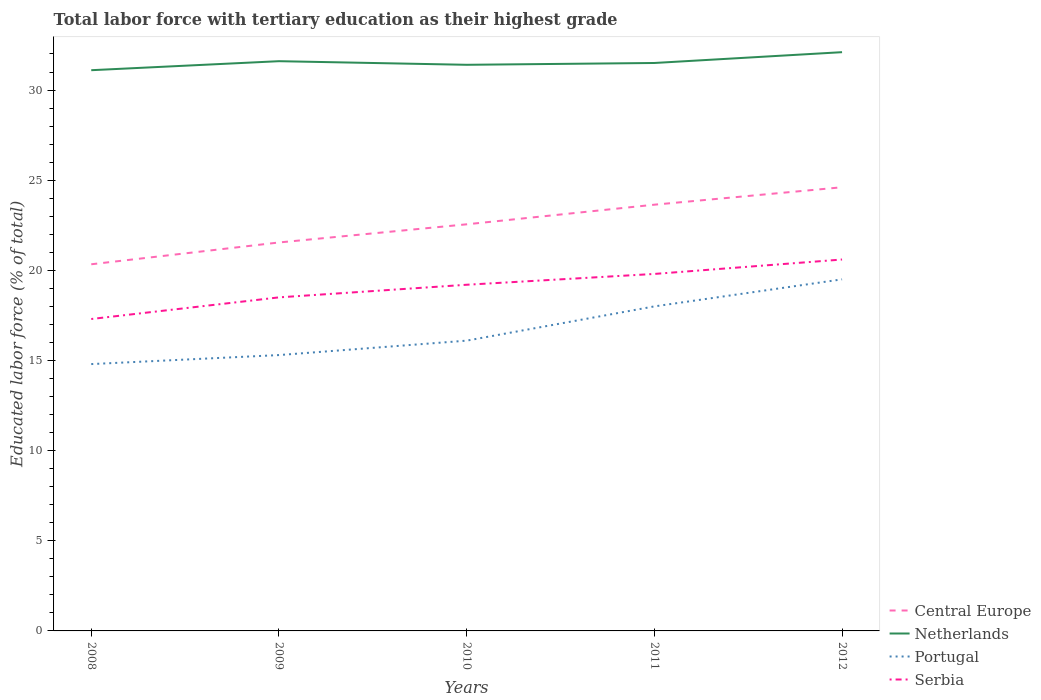How many different coloured lines are there?
Your answer should be compact. 4. Is the number of lines equal to the number of legend labels?
Ensure brevity in your answer.  Yes. Across all years, what is the maximum percentage of male labor force with tertiary education in Serbia?
Your answer should be very brief. 17.3. In which year was the percentage of male labor force with tertiary education in Netherlands maximum?
Make the answer very short. 2008. What is the total percentage of male labor force with tertiary education in Netherlands in the graph?
Ensure brevity in your answer.  0.2. What is the difference between the highest and the second highest percentage of male labor force with tertiary education in Central Europe?
Offer a terse response. 4.27. Is the percentage of male labor force with tertiary education in Central Europe strictly greater than the percentage of male labor force with tertiary education in Serbia over the years?
Your answer should be very brief. No. What is the difference between two consecutive major ticks on the Y-axis?
Make the answer very short. 5. Does the graph contain grids?
Offer a terse response. No. Where does the legend appear in the graph?
Provide a succinct answer. Bottom right. How many legend labels are there?
Provide a succinct answer. 4. What is the title of the graph?
Your answer should be very brief. Total labor force with tertiary education as their highest grade. What is the label or title of the Y-axis?
Ensure brevity in your answer.  Educated labor force (% of total). What is the Educated labor force (% of total) of Central Europe in 2008?
Ensure brevity in your answer.  20.34. What is the Educated labor force (% of total) of Netherlands in 2008?
Provide a short and direct response. 31.1. What is the Educated labor force (% of total) of Portugal in 2008?
Offer a very short reply. 14.8. What is the Educated labor force (% of total) of Serbia in 2008?
Your response must be concise. 17.3. What is the Educated labor force (% of total) of Central Europe in 2009?
Ensure brevity in your answer.  21.55. What is the Educated labor force (% of total) of Netherlands in 2009?
Make the answer very short. 31.6. What is the Educated labor force (% of total) in Portugal in 2009?
Give a very brief answer. 15.3. What is the Educated labor force (% of total) of Central Europe in 2010?
Your answer should be compact. 22.55. What is the Educated labor force (% of total) of Netherlands in 2010?
Your response must be concise. 31.4. What is the Educated labor force (% of total) in Portugal in 2010?
Offer a terse response. 16.1. What is the Educated labor force (% of total) in Serbia in 2010?
Your answer should be very brief. 19.2. What is the Educated labor force (% of total) in Central Europe in 2011?
Provide a short and direct response. 23.64. What is the Educated labor force (% of total) of Netherlands in 2011?
Your answer should be very brief. 31.5. What is the Educated labor force (% of total) of Portugal in 2011?
Make the answer very short. 18. What is the Educated labor force (% of total) in Serbia in 2011?
Ensure brevity in your answer.  19.8. What is the Educated labor force (% of total) in Central Europe in 2012?
Provide a short and direct response. 24.61. What is the Educated labor force (% of total) in Netherlands in 2012?
Provide a short and direct response. 32.1. What is the Educated labor force (% of total) of Serbia in 2012?
Offer a very short reply. 20.6. Across all years, what is the maximum Educated labor force (% of total) in Central Europe?
Ensure brevity in your answer.  24.61. Across all years, what is the maximum Educated labor force (% of total) in Netherlands?
Your response must be concise. 32.1. Across all years, what is the maximum Educated labor force (% of total) in Portugal?
Keep it short and to the point. 19.5. Across all years, what is the maximum Educated labor force (% of total) in Serbia?
Keep it short and to the point. 20.6. Across all years, what is the minimum Educated labor force (% of total) in Central Europe?
Provide a succinct answer. 20.34. Across all years, what is the minimum Educated labor force (% of total) of Netherlands?
Make the answer very short. 31.1. Across all years, what is the minimum Educated labor force (% of total) of Portugal?
Make the answer very short. 14.8. Across all years, what is the minimum Educated labor force (% of total) of Serbia?
Give a very brief answer. 17.3. What is the total Educated labor force (% of total) of Central Europe in the graph?
Your answer should be compact. 112.68. What is the total Educated labor force (% of total) of Netherlands in the graph?
Give a very brief answer. 157.7. What is the total Educated labor force (% of total) of Portugal in the graph?
Your response must be concise. 83.7. What is the total Educated labor force (% of total) of Serbia in the graph?
Provide a short and direct response. 95.4. What is the difference between the Educated labor force (% of total) in Central Europe in 2008 and that in 2009?
Your answer should be compact. -1.21. What is the difference between the Educated labor force (% of total) of Netherlands in 2008 and that in 2009?
Make the answer very short. -0.5. What is the difference between the Educated labor force (% of total) in Central Europe in 2008 and that in 2010?
Make the answer very short. -2.22. What is the difference between the Educated labor force (% of total) of Netherlands in 2008 and that in 2010?
Give a very brief answer. -0.3. What is the difference between the Educated labor force (% of total) in Portugal in 2008 and that in 2010?
Give a very brief answer. -1.3. What is the difference between the Educated labor force (% of total) of Central Europe in 2008 and that in 2011?
Provide a short and direct response. -3.3. What is the difference between the Educated labor force (% of total) in Portugal in 2008 and that in 2011?
Your response must be concise. -3.2. What is the difference between the Educated labor force (% of total) of Central Europe in 2008 and that in 2012?
Provide a short and direct response. -4.27. What is the difference between the Educated labor force (% of total) in Serbia in 2008 and that in 2012?
Your answer should be compact. -3.3. What is the difference between the Educated labor force (% of total) in Central Europe in 2009 and that in 2010?
Give a very brief answer. -1.01. What is the difference between the Educated labor force (% of total) of Netherlands in 2009 and that in 2010?
Give a very brief answer. 0.2. What is the difference between the Educated labor force (% of total) in Serbia in 2009 and that in 2010?
Provide a short and direct response. -0.7. What is the difference between the Educated labor force (% of total) of Central Europe in 2009 and that in 2011?
Your answer should be compact. -2.1. What is the difference between the Educated labor force (% of total) in Netherlands in 2009 and that in 2011?
Provide a succinct answer. 0.1. What is the difference between the Educated labor force (% of total) of Portugal in 2009 and that in 2011?
Give a very brief answer. -2.7. What is the difference between the Educated labor force (% of total) of Serbia in 2009 and that in 2011?
Provide a short and direct response. -1.3. What is the difference between the Educated labor force (% of total) in Central Europe in 2009 and that in 2012?
Give a very brief answer. -3.06. What is the difference between the Educated labor force (% of total) of Portugal in 2009 and that in 2012?
Your answer should be very brief. -4.2. What is the difference between the Educated labor force (% of total) in Central Europe in 2010 and that in 2011?
Provide a succinct answer. -1.09. What is the difference between the Educated labor force (% of total) in Netherlands in 2010 and that in 2011?
Ensure brevity in your answer.  -0.1. What is the difference between the Educated labor force (% of total) of Portugal in 2010 and that in 2011?
Give a very brief answer. -1.9. What is the difference between the Educated labor force (% of total) in Central Europe in 2010 and that in 2012?
Offer a terse response. -2.06. What is the difference between the Educated labor force (% of total) of Netherlands in 2010 and that in 2012?
Your answer should be compact. -0.7. What is the difference between the Educated labor force (% of total) in Portugal in 2010 and that in 2012?
Offer a terse response. -3.4. What is the difference between the Educated labor force (% of total) in Central Europe in 2011 and that in 2012?
Make the answer very short. -0.97. What is the difference between the Educated labor force (% of total) of Central Europe in 2008 and the Educated labor force (% of total) of Netherlands in 2009?
Provide a short and direct response. -11.26. What is the difference between the Educated labor force (% of total) in Central Europe in 2008 and the Educated labor force (% of total) in Portugal in 2009?
Give a very brief answer. 5.04. What is the difference between the Educated labor force (% of total) in Central Europe in 2008 and the Educated labor force (% of total) in Serbia in 2009?
Keep it short and to the point. 1.84. What is the difference between the Educated labor force (% of total) of Central Europe in 2008 and the Educated labor force (% of total) of Netherlands in 2010?
Ensure brevity in your answer.  -11.06. What is the difference between the Educated labor force (% of total) in Central Europe in 2008 and the Educated labor force (% of total) in Portugal in 2010?
Provide a succinct answer. 4.24. What is the difference between the Educated labor force (% of total) in Central Europe in 2008 and the Educated labor force (% of total) in Serbia in 2010?
Your answer should be compact. 1.14. What is the difference between the Educated labor force (% of total) in Netherlands in 2008 and the Educated labor force (% of total) in Portugal in 2010?
Keep it short and to the point. 15. What is the difference between the Educated labor force (% of total) of Netherlands in 2008 and the Educated labor force (% of total) of Serbia in 2010?
Offer a very short reply. 11.9. What is the difference between the Educated labor force (% of total) of Central Europe in 2008 and the Educated labor force (% of total) of Netherlands in 2011?
Make the answer very short. -11.16. What is the difference between the Educated labor force (% of total) of Central Europe in 2008 and the Educated labor force (% of total) of Portugal in 2011?
Provide a short and direct response. 2.34. What is the difference between the Educated labor force (% of total) in Central Europe in 2008 and the Educated labor force (% of total) in Serbia in 2011?
Offer a very short reply. 0.54. What is the difference between the Educated labor force (% of total) in Netherlands in 2008 and the Educated labor force (% of total) in Portugal in 2011?
Your answer should be very brief. 13.1. What is the difference between the Educated labor force (% of total) in Portugal in 2008 and the Educated labor force (% of total) in Serbia in 2011?
Your answer should be very brief. -5. What is the difference between the Educated labor force (% of total) of Central Europe in 2008 and the Educated labor force (% of total) of Netherlands in 2012?
Your response must be concise. -11.76. What is the difference between the Educated labor force (% of total) in Central Europe in 2008 and the Educated labor force (% of total) in Portugal in 2012?
Give a very brief answer. 0.84. What is the difference between the Educated labor force (% of total) in Central Europe in 2008 and the Educated labor force (% of total) in Serbia in 2012?
Give a very brief answer. -0.26. What is the difference between the Educated labor force (% of total) of Netherlands in 2008 and the Educated labor force (% of total) of Serbia in 2012?
Provide a succinct answer. 10.5. What is the difference between the Educated labor force (% of total) of Portugal in 2008 and the Educated labor force (% of total) of Serbia in 2012?
Your answer should be very brief. -5.8. What is the difference between the Educated labor force (% of total) of Central Europe in 2009 and the Educated labor force (% of total) of Netherlands in 2010?
Make the answer very short. -9.85. What is the difference between the Educated labor force (% of total) in Central Europe in 2009 and the Educated labor force (% of total) in Portugal in 2010?
Your response must be concise. 5.45. What is the difference between the Educated labor force (% of total) of Central Europe in 2009 and the Educated labor force (% of total) of Serbia in 2010?
Your response must be concise. 2.35. What is the difference between the Educated labor force (% of total) of Portugal in 2009 and the Educated labor force (% of total) of Serbia in 2010?
Your answer should be very brief. -3.9. What is the difference between the Educated labor force (% of total) of Central Europe in 2009 and the Educated labor force (% of total) of Netherlands in 2011?
Your response must be concise. -9.95. What is the difference between the Educated labor force (% of total) in Central Europe in 2009 and the Educated labor force (% of total) in Portugal in 2011?
Your answer should be compact. 3.55. What is the difference between the Educated labor force (% of total) in Central Europe in 2009 and the Educated labor force (% of total) in Serbia in 2011?
Offer a very short reply. 1.75. What is the difference between the Educated labor force (% of total) of Central Europe in 2009 and the Educated labor force (% of total) of Netherlands in 2012?
Keep it short and to the point. -10.55. What is the difference between the Educated labor force (% of total) in Central Europe in 2009 and the Educated labor force (% of total) in Portugal in 2012?
Ensure brevity in your answer.  2.05. What is the difference between the Educated labor force (% of total) of Central Europe in 2009 and the Educated labor force (% of total) of Serbia in 2012?
Provide a succinct answer. 0.95. What is the difference between the Educated labor force (% of total) in Netherlands in 2009 and the Educated labor force (% of total) in Portugal in 2012?
Offer a very short reply. 12.1. What is the difference between the Educated labor force (% of total) in Portugal in 2009 and the Educated labor force (% of total) in Serbia in 2012?
Make the answer very short. -5.3. What is the difference between the Educated labor force (% of total) of Central Europe in 2010 and the Educated labor force (% of total) of Netherlands in 2011?
Offer a very short reply. -8.95. What is the difference between the Educated labor force (% of total) of Central Europe in 2010 and the Educated labor force (% of total) of Portugal in 2011?
Offer a terse response. 4.55. What is the difference between the Educated labor force (% of total) in Central Europe in 2010 and the Educated labor force (% of total) in Serbia in 2011?
Make the answer very short. 2.75. What is the difference between the Educated labor force (% of total) of Netherlands in 2010 and the Educated labor force (% of total) of Portugal in 2011?
Your answer should be very brief. 13.4. What is the difference between the Educated labor force (% of total) of Netherlands in 2010 and the Educated labor force (% of total) of Serbia in 2011?
Offer a terse response. 11.6. What is the difference between the Educated labor force (% of total) in Portugal in 2010 and the Educated labor force (% of total) in Serbia in 2011?
Provide a short and direct response. -3.7. What is the difference between the Educated labor force (% of total) in Central Europe in 2010 and the Educated labor force (% of total) in Netherlands in 2012?
Your answer should be very brief. -9.55. What is the difference between the Educated labor force (% of total) in Central Europe in 2010 and the Educated labor force (% of total) in Portugal in 2012?
Keep it short and to the point. 3.05. What is the difference between the Educated labor force (% of total) of Central Europe in 2010 and the Educated labor force (% of total) of Serbia in 2012?
Provide a short and direct response. 1.95. What is the difference between the Educated labor force (% of total) of Netherlands in 2010 and the Educated labor force (% of total) of Serbia in 2012?
Your answer should be compact. 10.8. What is the difference between the Educated labor force (% of total) of Portugal in 2010 and the Educated labor force (% of total) of Serbia in 2012?
Your answer should be very brief. -4.5. What is the difference between the Educated labor force (% of total) of Central Europe in 2011 and the Educated labor force (% of total) of Netherlands in 2012?
Give a very brief answer. -8.46. What is the difference between the Educated labor force (% of total) in Central Europe in 2011 and the Educated labor force (% of total) in Portugal in 2012?
Make the answer very short. 4.14. What is the difference between the Educated labor force (% of total) in Central Europe in 2011 and the Educated labor force (% of total) in Serbia in 2012?
Offer a very short reply. 3.04. What is the difference between the Educated labor force (% of total) in Netherlands in 2011 and the Educated labor force (% of total) in Portugal in 2012?
Keep it short and to the point. 12. What is the difference between the Educated labor force (% of total) in Netherlands in 2011 and the Educated labor force (% of total) in Serbia in 2012?
Ensure brevity in your answer.  10.9. What is the difference between the Educated labor force (% of total) in Portugal in 2011 and the Educated labor force (% of total) in Serbia in 2012?
Your answer should be compact. -2.6. What is the average Educated labor force (% of total) of Central Europe per year?
Offer a terse response. 22.54. What is the average Educated labor force (% of total) of Netherlands per year?
Give a very brief answer. 31.54. What is the average Educated labor force (% of total) of Portugal per year?
Give a very brief answer. 16.74. What is the average Educated labor force (% of total) in Serbia per year?
Keep it short and to the point. 19.08. In the year 2008, what is the difference between the Educated labor force (% of total) in Central Europe and Educated labor force (% of total) in Netherlands?
Keep it short and to the point. -10.76. In the year 2008, what is the difference between the Educated labor force (% of total) of Central Europe and Educated labor force (% of total) of Portugal?
Your response must be concise. 5.54. In the year 2008, what is the difference between the Educated labor force (% of total) in Central Europe and Educated labor force (% of total) in Serbia?
Offer a very short reply. 3.04. In the year 2008, what is the difference between the Educated labor force (% of total) of Netherlands and Educated labor force (% of total) of Portugal?
Offer a very short reply. 16.3. In the year 2008, what is the difference between the Educated labor force (% of total) of Portugal and Educated labor force (% of total) of Serbia?
Provide a succinct answer. -2.5. In the year 2009, what is the difference between the Educated labor force (% of total) of Central Europe and Educated labor force (% of total) of Netherlands?
Make the answer very short. -10.05. In the year 2009, what is the difference between the Educated labor force (% of total) of Central Europe and Educated labor force (% of total) of Portugal?
Provide a short and direct response. 6.25. In the year 2009, what is the difference between the Educated labor force (% of total) of Central Europe and Educated labor force (% of total) of Serbia?
Offer a very short reply. 3.05. In the year 2009, what is the difference between the Educated labor force (% of total) of Netherlands and Educated labor force (% of total) of Portugal?
Your answer should be very brief. 16.3. In the year 2010, what is the difference between the Educated labor force (% of total) of Central Europe and Educated labor force (% of total) of Netherlands?
Make the answer very short. -8.85. In the year 2010, what is the difference between the Educated labor force (% of total) of Central Europe and Educated labor force (% of total) of Portugal?
Provide a short and direct response. 6.45. In the year 2010, what is the difference between the Educated labor force (% of total) in Central Europe and Educated labor force (% of total) in Serbia?
Your response must be concise. 3.35. In the year 2010, what is the difference between the Educated labor force (% of total) of Portugal and Educated labor force (% of total) of Serbia?
Provide a short and direct response. -3.1. In the year 2011, what is the difference between the Educated labor force (% of total) in Central Europe and Educated labor force (% of total) in Netherlands?
Your answer should be compact. -7.86. In the year 2011, what is the difference between the Educated labor force (% of total) in Central Europe and Educated labor force (% of total) in Portugal?
Your answer should be compact. 5.64. In the year 2011, what is the difference between the Educated labor force (% of total) of Central Europe and Educated labor force (% of total) of Serbia?
Ensure brevity in your answer.  3.84. In the year 2011, what is the difference between the Educated labor force (% of total) of Netherlands and Educated labor force (% of total) of Serbia?
Provide a succinct answer. 11.7. In the year 2011, what is the difference between the Educated labor force (% of total) of Portugal and Educated labor force (% of total) of Serbia?
Make the answer very short. -1.8. In the year 2012, what is the difference between the Educated labor force (% of total) of Central Europe and Educated labor force (% of total) of Netherlands?
Give a very brief answer. -7.49. In the year 2012, what is the difference between the Educated labor force (% of total) of Central Europe and Educated labor force (% of total) of Portugal?
Your response must be concise. 5.11. In the year 2012, what is the difference between the Educated labor force (% of total) in Central Europe and Educated labor force (% of total) in Serbia?
Provide a short and direct response. 4.01. What is the ratio of the Educated labor force (% of total) of Central Europe in 2008 to that in 2009?
Your response must be concise. 0.94. What is the ratio of the Educated labor force (% of total) of Netherlands in 2008 to that in 2009?
Your answer should be very brief. 0.98. What is the ratio of the Educated labor force (% of total) in Portugal in 2008 to that in 2009?
Provide a succinct answer. 0.97. What is the ratio of the Educated labor force (% of total) in Serbia in 2008 to that in 2009?
Offer a very short reply. 0.94. What is the ratio of the Educated labor force (% of total) of Central Europe in 2008 to that in 2010?
Your answer should be compact. 0.9. What is the ratio of the Educated labor force (% of total) of Portugal in 2008 to that in 2010?
Your answer should be compact. 0.92. What is the ratio of the Educated labor force (% of total) in Serbia in 2008 to that in 2010?
Offer a terse response. 0.9. What is the ratio of the Educated labor force (% of total) in Central Europe in 2008 to that in 2011?
Keep it short and to the point. 0.86. What is the ratio of the Educated labor force (% of total) in Netherlands in 2008 to that in 2011?
Provide a short and direct response. 0.99. What is the ratio of the Educated labor force (% of total) of Portugal in 2008 to that in 2011?
Offer a terse response. 0.82. What is the ratio of the Educated labor force (% of total) in Serbia in 2008 to that in 2011?
Your answer should be compact. 0.87. What is the ratio of the Educated labor force (% of total) of Central Europe in 2008 to that in 2012?
Provide a short and direct response. 0.83. What is the ratio of the Educated labor force (% of total) of Netherlands in 2008 to that in 2012?
Provide a short and direct response. 0.97. What is the ratio of the Educated labor force (% of total) of Portugal in 2008 to that in 2012?
Offer a terse response. 0.76. What is the ratio of the Educated labor force (% of total) in Serbia in 2008 to that in 2012?
Provide a short and direct response. 0.84. What is the ratio of the Educated labor force (% of total) of Central Europe in 2009 to that in 2010?
Offer a very short reply. 0.96. What is the ratio of the Educated labor force (% of total) of Netherlands in 2009 to that in 2010?
Offer a terse response. 1.01. What is the ratio of the Educated labor force (% of total) of Portugal in 2009 to that in 2010?
Provide a succinct answer. 0.95. What is the ratio of the Educated labor force (% of total) in Serbia in 2009 to that in 2010?
Provide a succinct answer. 0.96. What is the ratio of the Educated labor force (% of total) in Central Europe in 2009 to that in 2011?
Your answer should be compact. 0.91. What is the ratio of the Educated labor force (% of total) in Portugal in 2009 to that in 2011?
Your response must be concise. 0.85. What is the ratio of the Educated labor force (% of total) in Serbia in 2009 to that in 2011?
Provide a short and direct response. 0.93. What is the ratio of the Educated labor force (% of total) of Central Europe in 2009 to that in 2012?
Give a very brief answer. 0.88. What is the ratio of the Educated labor force (% of total) of Netherlands in 2009 to that in 2012?
Ensure brevity in your answer.  0.98. What is the ratio of the Educated labor force (% of total) of Portugal in 2009 to that in 2012?
Make the answer very short. 0.78. What is the ratio of the Educated labor force (% of total) of Serbia in 2009 to that in 2012?
Make the answer very short. 0.9. What is the ratio of the Educated labor force (% of total) in Central Europe in 2010 to that in 2011?
Provide a succinct answer. 0.95. What is the ratio of the Educated labor force (% of total) of Netherlands in 2010 to that in 2011?
Offer a terse response. 1. What is the ratio of the Educated labor force (% of total) in Portugal in 2010 to that in 2011?
Give a very brief answer. 0.89. What is the ratio of the Educated labor force (% of total) in Serbia in 2010 to that in 2011?
Provide a short and direct response. 0.97. What is the ratio of the Educated labor force (% of total) in Central Europe in 2010 to that in 2012?
Ensure brevity in your answer.  0.92. What is the ratio of the Educated labor force (% of total) in Netherlands in 2010 to that in 2012?
Give a very brief answer. 0.98. What is the ratio of the Educated labor force (% of total) of Portugal in 2010 to that in 2012?
Your answer should be very brief. 0.83. What is the ratio of the Educated labor force (% of total) in Serbia in 2010 to that in 2012?
Provide a succinct answer. 0.93. What is the ratio of the Educated labor force (% of total) in Central Europe in 2011 to that in 2012?
Ensure brevity in your answer.  0.96. What is the ratio of the Educated labor force (% of total) in Netherlands in 2011 to that in 2012?
Give a very brief answer. 0.98. What is the ratio of the Educated labor force (% of total) in Serbia in 2011 to that in 2012?
Your response must be concise. 0.96. What is the difference between the highest and the second highest Educated labor force (% of total) in Central Europe?
Make the answer very short. 0.97. What is the difference between the highest and the second highest Educated labor force (% of total) of Netherlands?
Offer a terse response. 0.5. What is the difference between the highest and the second highest Educated labor force (% of total) of Serbia?
Offer a very short reply. 0.8. What is the difference between the highest and the lowest Educated labor force (% of total) of Central Europe?
Provide a short and direct response. 4.27. What is the difference between the highest and the lowest Educated labor force (% of total) in Netherlands?
Your answer should be compact. 1. What is the difference between the highest and the lowest Educated labor force (% of total) in Portugal?
Your response must be concise. 4.7. 